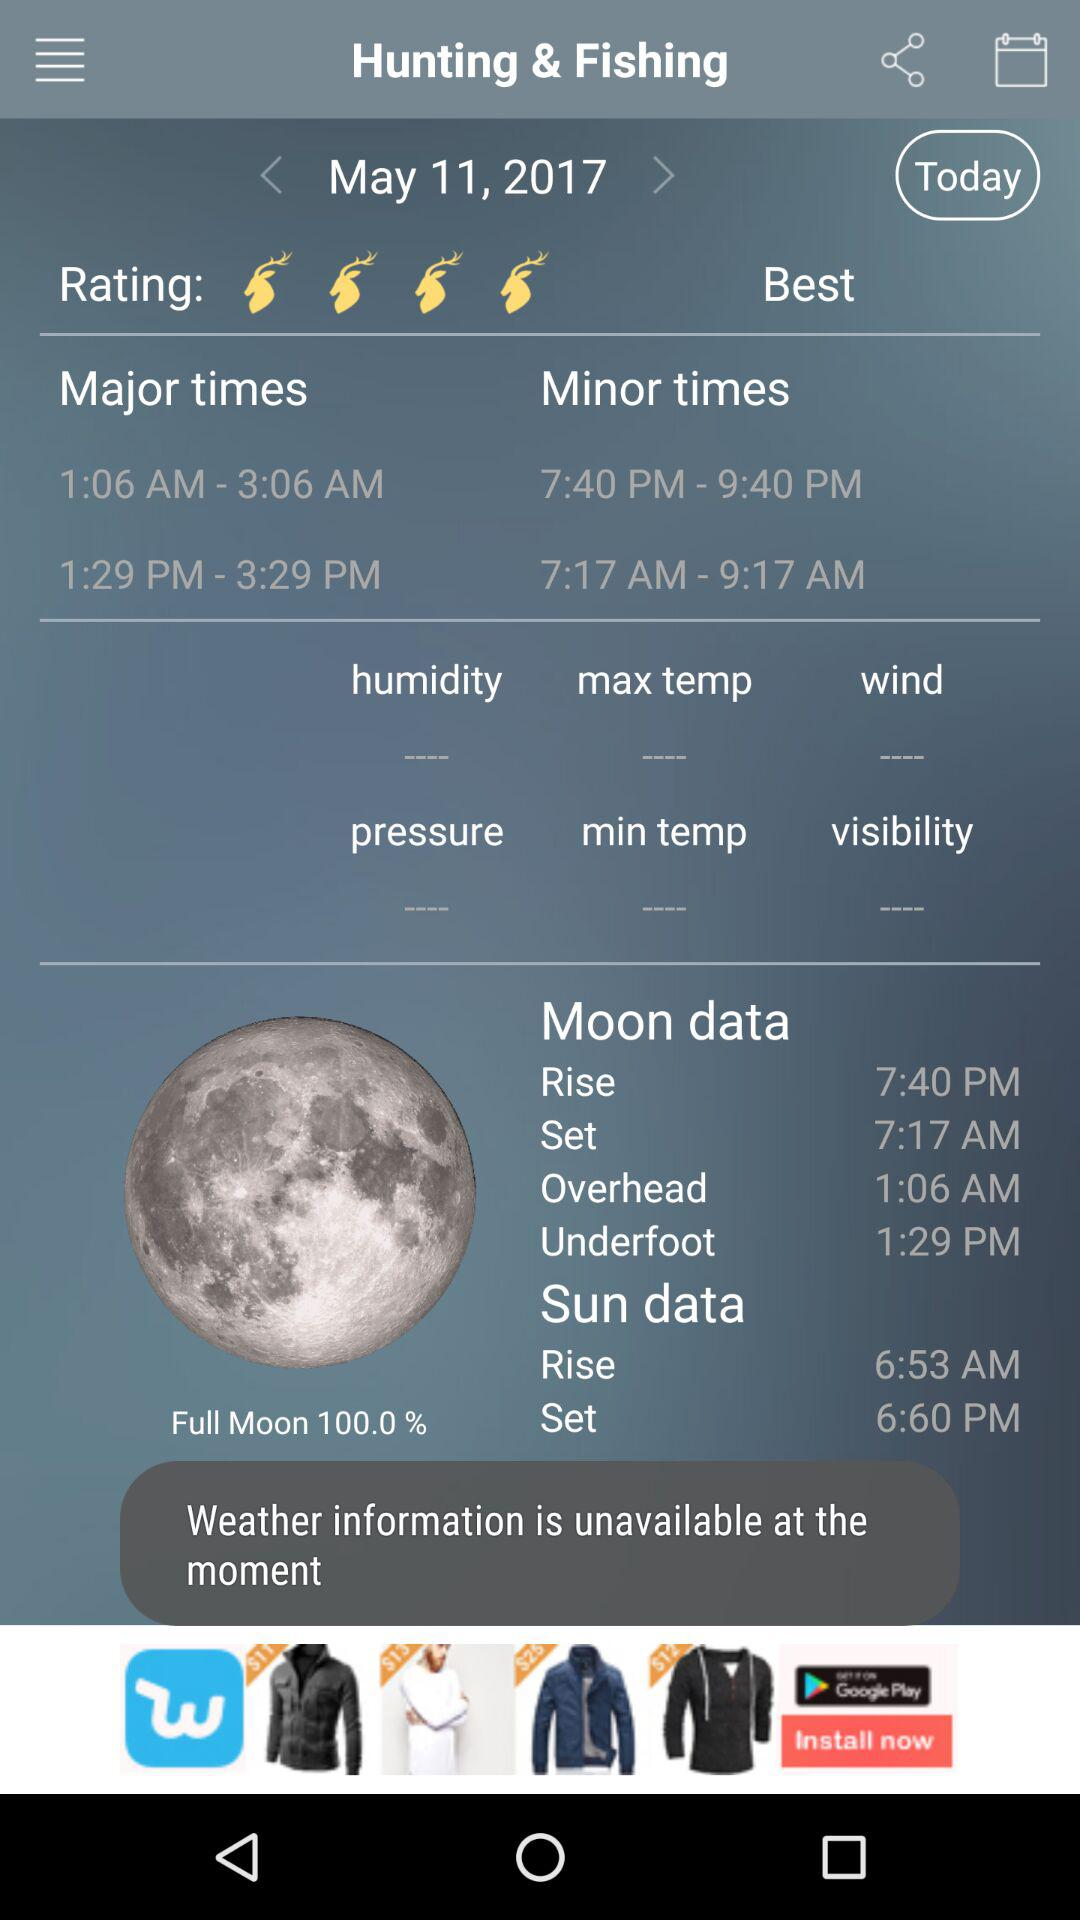When will the moon set? The moon will set at 7:17 AM. 